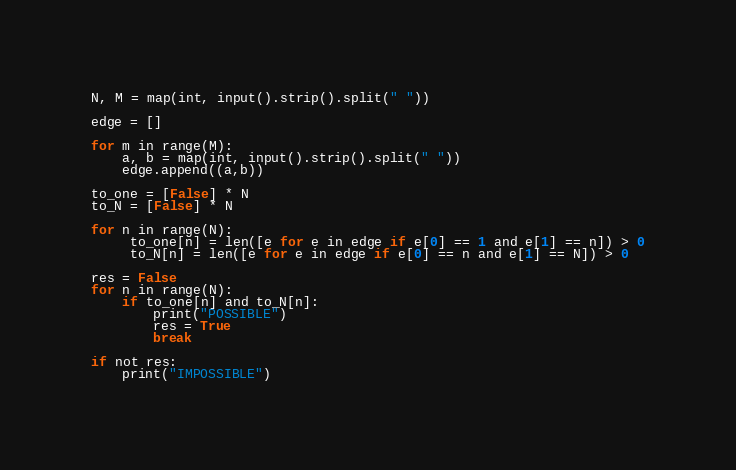Convert code to text. <code><loc_0><loc_0><loc_500><loc_500><_Python_>N, M = map(int, input().strip().split(" "))

edge = []

for m in range(M):
    a, b = map(int, input().strip().split(" "))
    edge.append((a,b))

to_one = [False] * N
to_N = [False] * N

for n in range(N):
     to_one[n] = len([e for e in edge if e[0] == 1 and e[1] == n]) > 0
     to_N[n] = len([e for e in edge if e[0] == n and e[1] == N]) > 0

res = False
for n in range(N):
    if to_one[n] and to_N[n]:
        print("POSSIBLE")
        res = True
        break

if not res:
    print("IMPOSSIBLE")</code> 